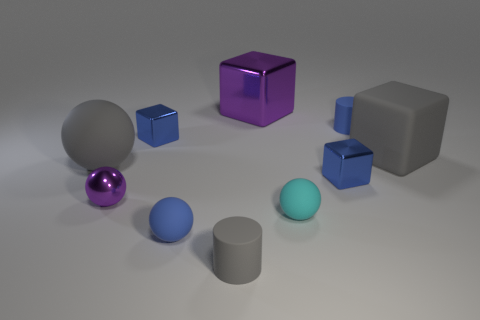There is a small object that is the same color as the matte block; what is its shape?
Ensure brevity in your answer.  Cylinder. What size is the rubber cylinder that is the same color as the large rubber ball?
Your answer should be very brief. Small. How many tiny objects are either green shiny cylinders or matte things?
Provide a short and direct response. 4. What is the big purple thing made of?
Provide a succinct answer. Metal. How many other objects are there of the same shape as the small gray thing?
Provide a succinct answer. 1. The gray rubber ball is what size?
Ensure brevity in your answer.  Large. There is a matte object that is both behind the tiny cyan rubber thing and to the left of the large purple metallic object; what is its size?
Provide a succinct answer. Large. What is the shape of the large gray matte thing on the left side of the tiny metal ball?
Provide a succinct answer. Sphere. Is the big purple object made of the same material as the small blue thing that is in front of the small metal sphere?
Provide a succinct answer. No. Is the shape of the small gray rubber object the same as the tiny cyan object?
Offer a terse response. No. 